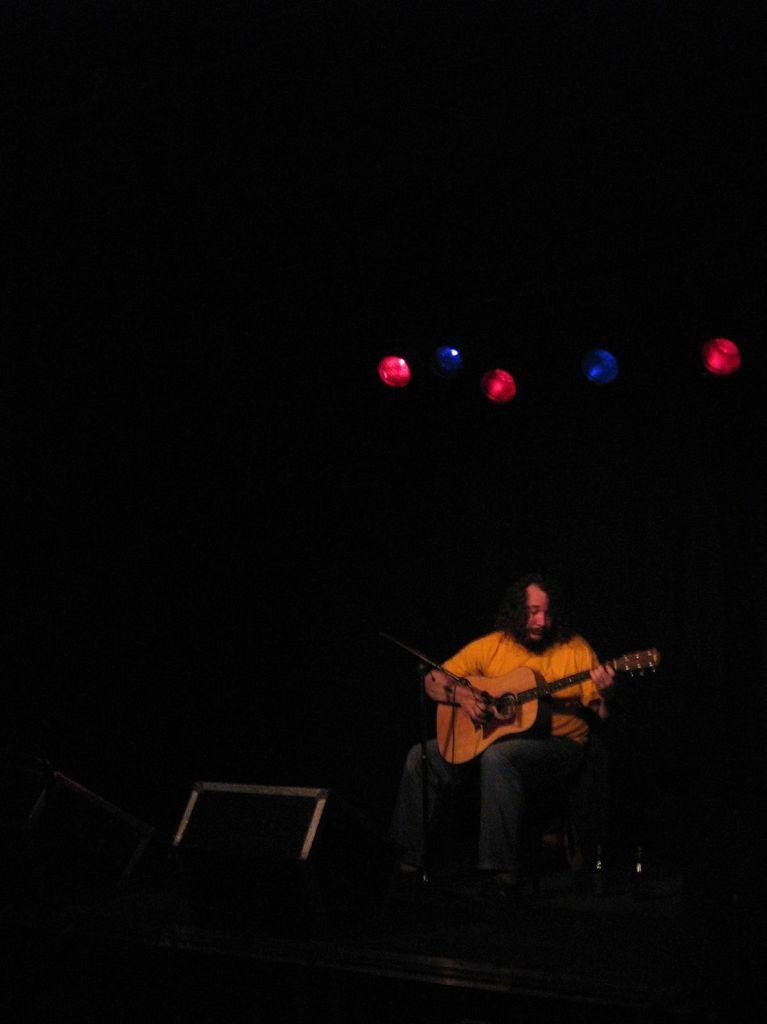What is the man in the image doing? The man is sitting and playing a guitar in the image. What object is in front of the man? There is a speaker in front of the man. What can be seen in the background of the image? There are five lights in the background of the image. What is the color of the background in the image? The background of the image is in dark color. What other materials are present in front of the man? There are other materials in front of the man, but their specific nature is not mentioned in the facts. What type of shoes is the man wearing in the image? There is no mention of shoes in the image, so we cannot determine what type of shoes the man is wearing. What kind of soup is being prepared in the image? There is no soup or any cooking activity present in the image. 